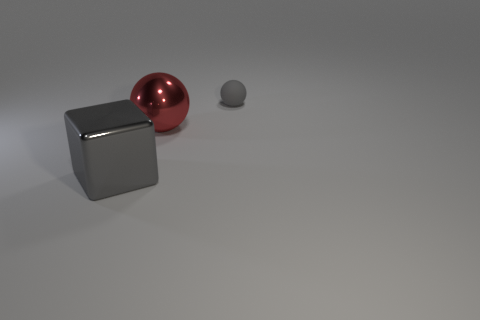There is a ball that is the same color as the shiny block; what size is it?
Offer a very short reply. Small. There is another large thing that is the same color as the rubber object; what is its material?
Your answer should be very brief. Metal. There is a gray thing that is behind the gray metal block; is its size the same as the red ball?
Your answer should be compact. No. The big metal sphere is what color?
Your answer should be very brief. Red. What is the color of the ball that is in front of the gray thing behind the cube?
Your response must be concise. Red. Is there a big red ball that has the same material as the tiny ball?
Offer a very short reply. No. What material is the gray object that is in front of the ball that is on the right side of the red object?
Give a very brief answer. Metal. How many other gray metal objects are the same shape as the small gray object?
Your answer should be compact. 0. The large red metallic thing is what shape?
Provide a short and direct response. Sphere. Is the number of red metallic things less than the number of large red matte cylinders?
Make the answer very short. No. 